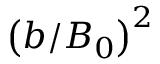Convert formula to latex. <formula><loc_0><loc_0><loc_500><loc_500>\left ( b / B _ { 0 } \right ) ^ { 2 }</formula> 